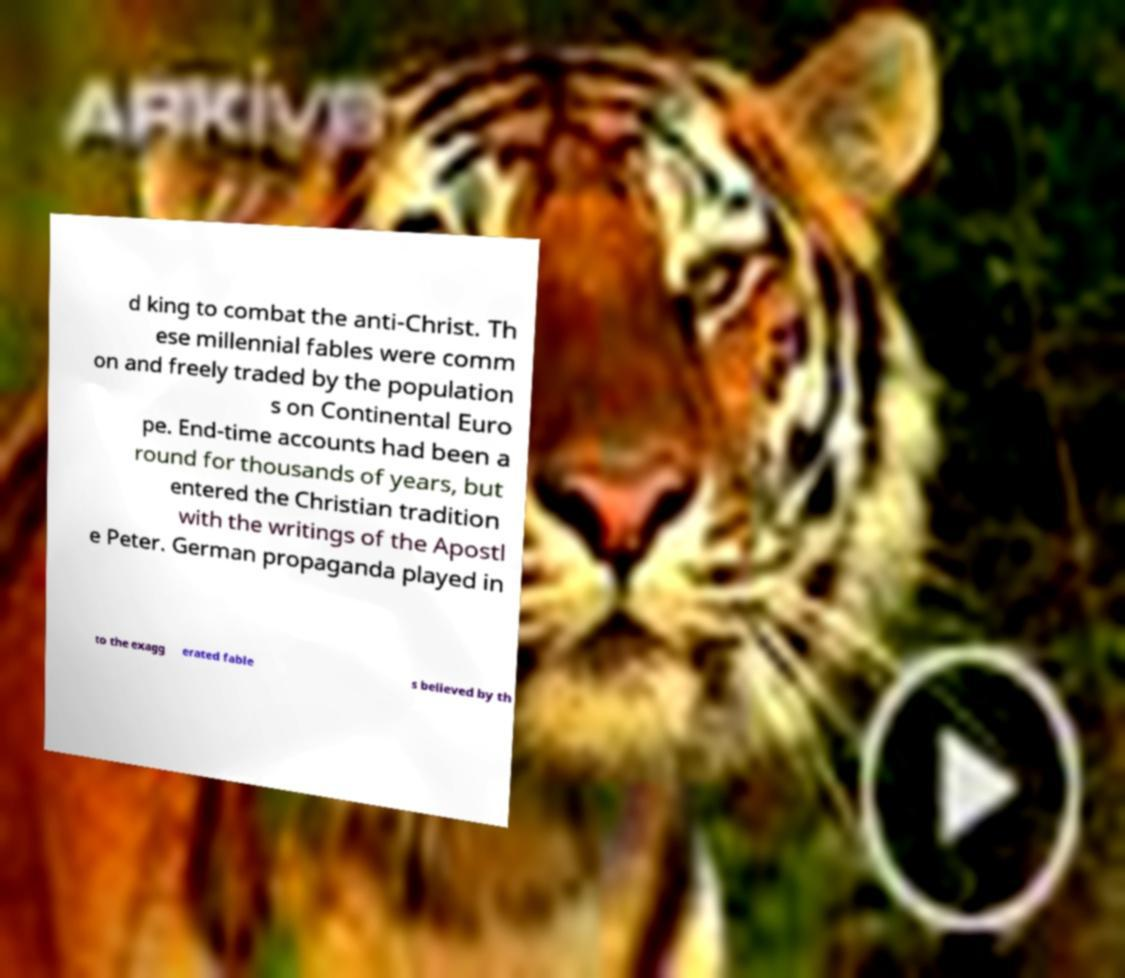Can you accurately transcribe the text from the provided image for me? d king to combat the anti-Christ. Th ese millennial fables were comm on and freely traded by the population s on Continental Euro pe. End-time accounts had been a round for thousands of years, but entered the Christian tradition with the writings of the Apostl e Peter. German propaganda played in to the exagg erated fable s believed by th 